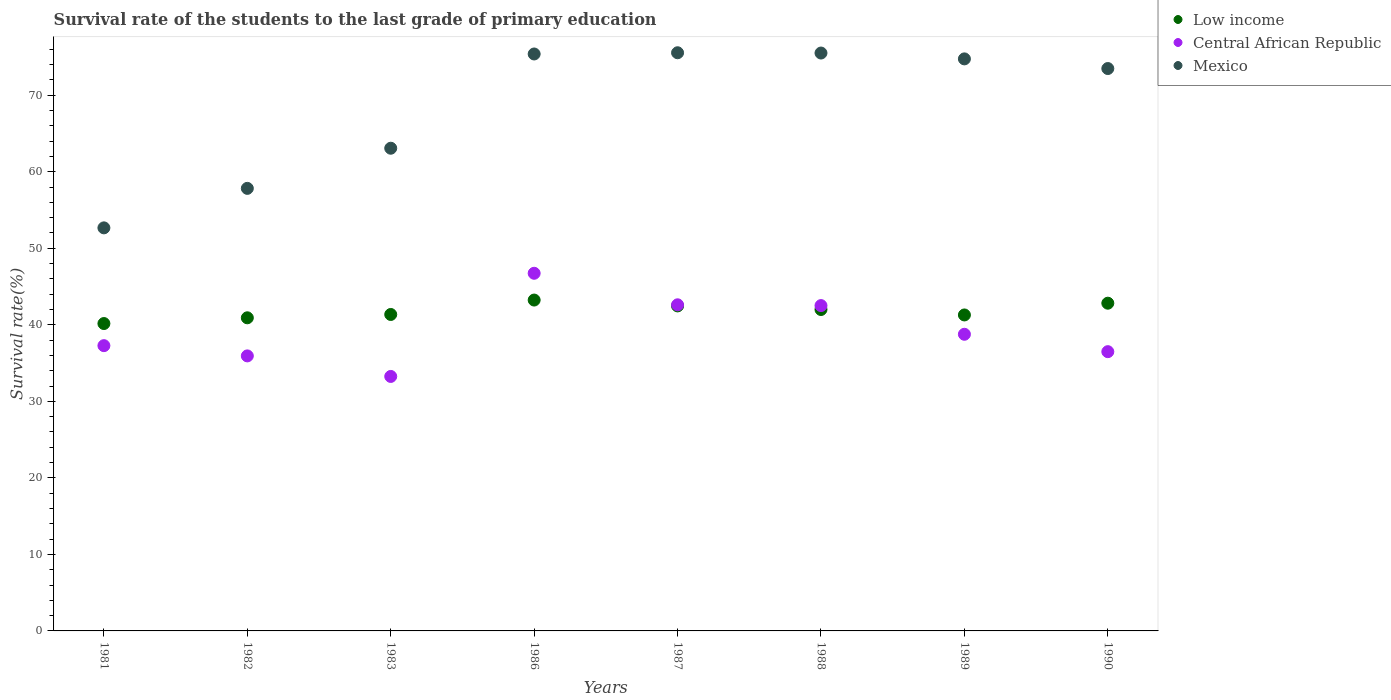Is the number of dotlines equal to the number of legend labels?
Provide a short and direct response. Yes. What is the survival rate of the students in Mexico in 1988?
Make the answer very short. 75.51. Across all years, what is the maximum survival rate of the students in Low income?
Keep it short and to the point. 43.23. Across all years, what is the minimum survival rate of the students in Low income?
Your answer should be very brief. 40.16. What is the total survival rate of the students in Low income in the graph?
Make the answer very short. 334.23. What is the difference between the survival rate of the students in Central African Republic in 1983 and that in 1988?
Provide a succinct answer. -9.26. What is the difference between the survival rate of the students in Low income in 1989 and the survival rate of the students in Central African Republic in 1987?
Provide a short and direct response. -1.33. What is the average survival rate of the students in Mexico per year?
Make the answer very short. 68.53. In the year 1989, what is the difference between the survival rate of the students in Low income and survival rate of the students in Central African Republic?
Provide a succinct answer. 2.52. What is the ratio of the survival rate of the students in Central African Republic in 1983 to that in 1987?
Make the answer very short. 0.78. Is the survival rate of the students in Low income in 1982 less than that in 1987?
Your answer should be compact. Yes. Is the difference between the survival rate of the students in Low income in 1988 and 1989 greater than the difference between the survival rate of the students in Central African Republic in 1988 and 1989?
Keep it short and to the point. No. What is the difference between the highest and the second highest survival rate of the students in Central African Republic?
Make the answer very short. 4.12. What is the difference between the highest and the lowest survival rate of the students in Central African Republic?
Offer a terse response. 13.48. In how many years, is the survival rate of the students in Central African Republic greater than the average survival rate of the students in Central African Republic taken over all years?
Keep it short and to the point. 3. Is the sum of the survival rate of the students in Central African Republic in 1986 and 1987 greater than the maximum survival rate of the students in Mexico across all years?
Ensure brevity in your answer.  Yes. Is it the case that in every year, the sum of the survival rate of the students in Central African Republic and survival rate of the students in Mexico  is greater than the survival rate of the students in Low income?
Your answer should be very brief. Yes. Does the survival rate of the students in Central African Republic monotonically increase over the years?
Your answer should be very brief. No. Is the survival rate of the students in Central African Republic strictly greater than the survival rate of the students in Mexico over the years?
Ensure brevity in your answer.  No. Is the survival rate of the students in Mexico strictly less than the survival rate of the students in Central African Republic over the years?
Offer a very short reply. No. How many dotlines are there?
Provide a succinct answer. 3. How many years are there in the graph?
Offer a very short reply. 8. Are the values on the major ticks of Y-axis written in scientific E-notation?
Provide a short and direct response. No. Where does the legend appear in the graph?
Keep it short and to the point. Top right. How many legend labels are there?
Provide a short and direct response. 3. How are the legend labels stacked?
Offer a very short reply. Vertical. What is the title of the graph?
Offer a very short reply. Survival rate of the students to the last grade of primary education. What is the label or title of the X-axis?
Your answer should be very brief. Years. What is the label or title of the Y-axis?
Your answer should be compact. Survival rate(%). What is the Survival rate(%) of Low income in 1981?
Make the answer very short. 40.16. What is the Survival rate(%) of Central African Republic in 1981?
Keep it short and to the point. 37.27. What is the Survival rate(%) in Mexico in 1981?
Give a very brief answer. 52.67. What is the Survival rate(%) in Low income in 1982?
Provide a short and direct response. 40.91. What is the Survival rate(%) in Central African Republic in 1982?
Keep it short and to the point. 35.94. What is the Survival rate(%) of Mexico in 1982?
Offer a very short reply. 57.83. What is the Survival rate(%) of Low income in 1983?
Make the answer very short. 41.35. What is the Survival rate(%) of Central African Republic in 1983?
Make the answer very short. 33.25. What is the Survival rate(%) of Mexico in 1983?
Your answer should be very brief. 63.07. What is the Survival rate(%) of Low income in 1986?
Your answer should be very brief. 43.23. What is the Survival rate(%) in Central African Republic in 1986?
Provide a short and direct response. 46.73. What is the Survival rate(%) of Mexico in 1986?
Provide a short and direct response. 75.39. What is the Survival rate(%) of Low income in 1987?
Your answer should be very brief. 42.47. What is the Survival rate(%) in Central African Republic in 1987?
Offer a very short reply. 42.61. What is the Survival rate(%) of Mexico in 1987?
Keep it short and to the point. 75.55. What is the Survival rate(%) of Low income in 1988?
Make the answer very short. 42. What is the Survival rate(%) of Central African Republic in 1988?
Your answer should be very brief. 42.51. What is the Survival rate(%) in Mexico in 1988?
Offer a terse response. 75.51. What is the Survival rate(%) of Low income in 1989?
Your answer should be compact. 41.29. What is the Survival rate(%) of Central African Republic in 1989?
Keep it short and to the point. 38.76. What is the Survival rate(%) in Mexico in 1989?
Give a very brief answer. 74.74. What is the Survival rate(%) in Low income in 1990?
Provide a short and direct response. 42.82. What is the Survival rate(%) of Central African Republic in 1990?
Your answer should be compact. 36.49. What is the Survival rate(%) of Mexico in 1990?
Ensure brevity in your answer.  73.48. Across all years, what is the maximum Survival rate(%) in Low income?
Make the answer very short. 43.23. Across all years, what is the maximum Survival rate(%) of Central African Republic?
Make the answer very short. 46.73. Across all years, what is the maximum Survival rate(%) in Mexico?
Your answer should be compact. 75.55. Across all years, what is the minimum Survival rate(%) of Low income?
Provide a short and direct response. 40.16. Across all years, what is the minimum Survival rate(%) in Central African Republic?
Ensure brevity in your answer.  33.25. Across all years, what is the minimum Survival rate(%) in Mexico?
Make the answer very short. 52.67. What is the total Survival rate(%) of Low income in the graph?
Give a very brief answer. 334.23. What is the total Survival rate(%) in Central African Republic in the graph?
Your answer should be compact. 313.57. What is the total Survival rate(%) in Mexico in the graph?
Offer a terse response. 548.23. What is the difference between the Survival rate(%) of Low income in 1981 and that in 1982?
Your answer should be very brief. -0.75. What is the difference between the Survival rate(%) in Central African Republic in 1981 and that in 1982?
Give a very brief answer. 1.34. What is the difference between the Survival rate(%) in Mexico in 1981 and that in 1982?
Keep it short and to the point. -5.16. What is the difference between the Survival rate(%) of Low income in 1981 and that in 1983?
Your answer should be compact. -1.18. What is the difference between the Survival rate(%) in Central African Republic in 1981 and that in 1983?
Provide a short and direct response. 4.02. What is the difference between the Survival rate(%) of Mexico in 1981 and that in 1983?
Provide a succinct answer. -10.4. What is the difference between the Survival rate(%) of Low income in 1981 and that in 1986?
Offer a very short reply. -3.07. What is the difference between the Survival rate(%) of Central African Republic in 1981 and that in 1986?
Make the answer very short. -9.46. What is the difference between the Survival rate(%) in Mexico in 1981 and that in 1986?
Give a very brief answer. -22.72. What is the difference between the Survival rate(%) of Low income in 1981 and that in 1987?
Give a very brief answer. -2.3. What is the difference between the Survival rate(%) of Central African Republic in 1981 and that in 1987?
Provide a short and direct response. -5.34. What is the difference between the Survival rate(%) of Mexico in 1981 and that in 1987?
Your answer should be very brief. -22.88. What is the difference between the Survival rate(%) in Low income in 1981 and that in 1988?
Ensure brevity in your answer.  -1.83. What is the difference between the Survival rate(%) of Central African Republic in 1981 and that in 1988?
Your answer should be compact. -5.23. What is the difference between the Survival rate(%) in Mexico in 1981 and that in 1988?
Keep it short and to the point. -22.84. What is the difference between the Survival rate(%) in Low income in 1981 and that in 1989?
Your answer should be very brief. -1.12. What is the difference between the Survival rate(%) of Central African Republic in 1981 and that in 1989?
Make the answer very short. -1.49. What is the difference between the Survival rate(%) in Mexico in 1981 and that in 1989?
Give a very brief answer. -22.08. What is the difference between the Survival rate(%) in Low income in 1981 and that in 1990?
Offer a terse response. -2.66. What is the difference between the Survival rate(%) in Central African Republic in 1981 and that in 1990?
Ensure brevity in your answer.  0.79. What is the difference between the Survival rate(%) of Mexico in 1981 and that in 1990?
Provide a succinct answer. -20.82. What is the difference between the Survival rate(%) of Low income in 1982 and that in 1983?
Offer a very short reply. -0.44. What is the difference between the Survival rate(%) in Central African Republic in 1982 and that in 1983?
Keep it short and to the point. 2.68. What is the difference between the Survival rate(%) in Mexico in 1982 and that in 1983?
Make the answer very short. -5.25. What is the difference between the Survival rate(%) in Low income in 1982 and that in 1986?
Ensure brevity in your answer.  -2.32. What is the difference between the Survival rate(%) in Central African Republic in 1982 and that in 1986?
Keep it short and to the point. -10.8. What is the difference between the Survival rate(%) in Mexico in 1982 and that in 1986?
Your answer should be very brief. -17.56. What is the difference between the Survival rate(%) in Low income in 1982 and that in 1987?
Offer a terse response. -1.55. What is the difference between the Survival rate(%) of Central African Republic in 1982 and that in 1987?
Keep it short and to the point. -6.68. What is the difference between the Survival rate(%) in Mexico in 1982 and that in 1987?
Ensure brevity in your answer.  -17.72. What is the difference between the Survival rate(%) of Low income in 1982 and that in 1988?
Ensure brevity in your answer.  -1.08. What is the difference between the Survival rate(%) in Central African Republic in 1982 and that in 1988?
Keep it short and to the point. -6.57. What is the difference between the Survival rate(%) of Mexico in 1982 and that in 1988?
Ensure brevity in your answer.  -17.68. What is the difference between the Survival rate(%) in Low income in 1982 and that in 1989?
Offer a terse response. -0.37. What is the difference between the Survival rate(%) of Central African Republic in 1982 and that in 1989?
Give a very brief answer. -2.83. What is the difference between the Survival rate(%) in Mexico in 1982 and that in 1989?
Keep it short and to the point. -16.92. What is the difference between the Survival rate(%) in Low income in 1982 and that in 1990?
Your answer should be compact. -1.91. What is the difference between the Survival rate(%) in Central African Republic in 1982 and that in 1990?
Give a very brief answer. -0.55. What is the difference between the Survival rate(%) in Mexico in 1982 and that in 1990?
Make the answer very short. -15.66. What is the difference between the Survival rate(%) in Low income in 1983 and that in 1986?
Provide a succinct answer. -1.88. What is the difference between the Survival rate(%) of Central African Republic in 1983 and that in 1986?
Keep it short and to the point. -13.48. What is the difference between the Survival rate(%) of Mexico in 1983 and that in 1986?
Keep it short and to the point. -12.31. What is the difference between the Survival rate(%) of Low income in 1983 and that in 1987?
Your answer should be very brief. -1.12. What is the difference between the Survival rate(%) of Central African Republic in 1983 and that in 1987?
Your answer should be compact. -9.36. What is the difference between the Survival rate(%) of Mexico in 1983 and that in 1987?
Your answer should be very brief. -12.47. What is the difference between the Survival rate(%) of Low income in 1983 and that in 1988?
Offer a very short reply. -0.65. What is the difference between the Survival rate(%) in Central African Republic in 1983 and that in 1988?
Your response must be concise. -9.26. What is the difference between the Survival rate(%) of Mexico in 1983 and that in 1988?
Provide a short and direct response. -12.44. What is the difference between the Survival rate(%) in Low income in 1983 and that in 1989?
Offer a very short reply. 0.06. What is the difference between the Survival rate(%) in Central African Republic in 1983 and that in 1989?
Offer a terse response. -5.51. What is the difference between the Survival rate(%) in Mexico in 1983 and that in 1989?
Offer a very short reply. -11.67. What is the difference between the Survival rate(%) in Low income in 1983 and that in 1990?
Provide a succinct answer. -1.47. What is the difference between the Survival rate(%) of Central African Republic in 1983 and that in 1990?
Give a very brief answer. -3.24. What is the difference between the Survival rate(%) of Mexico in 1983 and that in 1990?
Your answer should be compact. -10.41. What is the difference between the Survival rate(%) of Low income in 1986 and that in 1987?
Keep it short and to the point. 0.77. What is the difference between the Survival rate(%) of Central African Republic in 1986 and that in 1987?
Offer a terse response. 4.12. What is the difference between the Survival rate(%) of Mexico in 1986 and that in 1987?
Provide a short and direct response. -0.16. What is the difference between the Survival rate(%) in Low income in 1986 and that in 1988?
Offer a terse response. 1.24. What is the difference between the Survival rate(%) in Central African Republic in 1986 and that in 1988?
Keep it short and to the point. 4.22. What is the difference between the Survival rate(%) in Mexico in 1986 and that in 1988?
Make the answer very short. -0.12. What is the difference between the Survival rate(%) in Low income in 1986 and that in 1989?
Make the answer very short. 1.95. What is the difference between the Survival rate(%) of Central African Republic in 1986 and that in 1989?
Offer a terse response. 7.97. What is the difference between the Survival rate(%) in Mexico in 1986 and that in 1989?
Give a very brief answer. 0.64. What is the difference between the Survival rate(%) in Low income in 1986 and that in 1990?
Provide a short and direct response. 0.41. What is the difference between the Survival rate(%) in Central African Republic in 1986 and that in 1990?
Your response must be concise. 10.24. What is the difference between the Survival rate(%) of Mexico in 1986 and that in 1990?
Provide a short and direct response. 1.9. What is the difference between the Survival rate(%) of Low income in 1987 and that in 1988?
Provide a succinct answer. 0.47. What is the difference between the Survival rate(%) of Central African Republic in 1987 and that in 1988?
Provide a short and direct response. 0.1. What is the difference between the Survival rate(%) in Mexico in 1987 and that in 1988?
Keep it short and to the point. 0.04. What is the difference between the Survival rate(%) in Low income in 1987 and that in 1989?
Make the answer very short. 1.18. What is the difference between the Survival rate(%) in Central African Republic in 1987 and that in 1989?
Offer a terse response. 3.85. What is the difference between the Survival rate(%) in Mexico in 1987 and that in 1989?
Give a very brief answer. 0.8. What is the difference between the Survival rate(%) of Low income in 1987 and that in 1990?
Your response must be concise. -0.35. What is the difference between the Survival rate(%) of Central African Republic in 1987 and that in 1990?
Keep it short and to the point. 6.12. What is the difference between the Survival rate(%) of Mexico in 1987 and that in 1990?
Your answer should be compact. 2.06. What is the difference between the Survival rate(%) in Low income in 1988 and that in 1989?
Make the answer very short. 0.71. What is the difference between the Survival rate(%) in Central African Republic in 1988 and that in 1989?
Keep it short and to the point. 3.75. What is the difference between the Survival rate(%) in Mexico in 1988 and that in 1989?
Offer a very short reply. 0.76. What is the difference between the Survival rate(%) of Low income in 1988 and that in 1990?
Provide a short and direct response. -0.82. What is the difference between the Survival rate(%) of Central African Republic in 1988 and that in 1990?
Offer a very short reply. 6.02. What is the difference between the Survival rate(%) in Mexico in 1988 and that in 1990?
Your answer should be compact. 2.03. What is the difference between the Survival rate(%) in Low income in 1989 and that in 1990?
Offer a terse response. -1.54. What is the difference between the Survival rate(%) of Central African Republic in 1989 and that in 1990?
Your response must be concise. 2.27. What is the difference between the Survival rate(%) in Mexico in 1989 and that in 1990?
Keep it short and to the point. 1.26. What is the difference between the Survival rate(%) of Low income in 1981 and the Survival rate(%) of Central African Republic in 1982?
Keep it short and to the point. 4.23. What is the difference between the Survival rate(%) of Low income in 1981 and the Survival rate(%) of Mexico in 1982?
Your answer should be very brief. -17.66. What is the difference between the Survival rate(%) in Central African Republic in 1981 and the Survival rate(%) in Mexico in 1982?
Offer a terse response. -20.55. What is the difference between the Survival rate(%) in Low income in 1981 and the Survival rate(%) in Central African Republic in 1983?
Offer a very short reply. 6.91. What is the difference between the Survival rate(%) in Low income in 1981 and the Survival rate(%) in Mexico in 1983?
Your answer should be very brief. -22.91. What is the difference between the Survival rate(%) of Central African Republic in 1981 and the Survival rate(%) of Mexico in 1983?
Your answer should be compact. -25.8. What is the difference between the Survival rate(%) in Low income in 1981 and the Survival rate(%) in Central African Republic in 1986?
Keep it short and to the point. -6.57. What is the difference between the Survival rate(%) of Low income in 1981 and the Survival rate(%) of Mexico in 1986?
Provide a succinct answer. -35.22. What is the difference between the Survival rate(%) in Central African Republic in 1981 and the Survival rate(%) in Mexico in 1986?
Give a very brief answer. -38.11. What is the difference between the Survival rate(%) of Low income in 1981 and the Survival rate(%) of Central African Republic in 1987?
Offer a very short reply. -2.45. What is the difference between the Survival rate(%) of Low income in 1981 and the Survival rate(%) of Mexico in 1987?
Ensure brevity in your answer.  -35.38. What is the difference between the Survival rate(%) of Central African Republic in 1981 and the Survival rate(%) of Mexico in 1987?
Offer a terse response. -38.27. What is the difference between the Survival rate(%) in Low income in 1981 and the Survival rate(%) in Central African Republic in 1988?
Your answer should be compact. -2.35. What is the difference between the Survival rate(%) in Low income in 1981 and the Survival rate(%) in Mexico in 1988?
Your response must be concise. -35.34. What is the difference between the Survival rate(%) in Central African Republic in 1981 and the Survival rate(%) in Mexico in 1988?
Ensure brevity in your answer.  -38.23. What is the difference between the Survival rate(%) of Low income in 1981 and the Survival rate(%) of Central African Republic in 1989?
Your answer should be very brief. 1.4. What is the difference between the Survival rate(%) in Low income in 1981 and the Survival rate(%) in Mexico in 1989?
Offer a very short reply. -34.58. What is the difference between the Survival rate(%) of Central African Republic in 1981 and the Survival rate(%) of Mexico in 1989?
Offer a terse response. -37.47. What is the difference between the Survival rate(%) of Low income in 1981 and the Survival rate(%) of Central African Republic in 1990?
Your answer should be compact. 3.68. What is the difference between the Survival rate(%) of Low income in 1981 and the Survival rate(%) of Mexico in 1990?
Your response must be concise. -33.32. What is the difference between the Survival rate(%) in Central African Republic in 1981 and the Survival rate(%) in Mexico in 1990?
Give a very brief answer. -36.21. What is the difference between the Survival rate(%) of Low income in 1982 and the Survival rate(%) of Central African Republic in 1983?
Your answer should be very brief. 7.66. What is the difference between the Survival rate(%) in Low income in 1982 and the Survival rate(%) in Mexico in 1983?
Ensure brevity in your answer.  -22.16. What is the difference between the Survival rate(%) in Central African Republic in 1982 and the Survival rate(%) in Mexico in 1983?
Keep it short and to the point. -27.14. What is the difference between the Survival rate(%) of Low income in 1982 and the Survival rate(%) of Central African Republic in 1986?
Your answer should be very brief. -5.82. What is the difference between the Survival rate(%) of Low income in 1982 and the Survival rate(%) of Mexico in 1986?
Provide a succinct answer. -34.47. What is the difference between the Survival rate(%) in Central African Republic in 1982 and the Survival rate(%) in Mexico in 1986?
Your answer should be compact. -39.45. What is the difference between the Survival rate(%) in Low income in 1982 and the Survival rate(%) in Central African Republic in 1987?
Make the answer very short. -1.7. What is the difference between the Survival rate(%) of Low income in 1982 and the Survival rate(%) of Mexico in 1987?
Your response must be concise. -34.63. What is the difference between the Survival rate(%) in Central African Republic in 1982 and the Survival rate(%) in Mexico in 1987?
Your answer should be compact. -39.61. What is the difference between the Survival rate(%) of Low income in 1982 and the Survival rate(%) of Central African Republic in 1988?
Keep it short and to the point. -1.6. What is the difference between the Survival rate(%) in Low income in 1982 and the Survival rate(%) in Mexico in 1988?
Your answer should be compact. -34.6. What is the difference between the Survival rate(%) of Central African Republic in 1982 and the Survival rate(%) of Mexico in 1988?
Give a very brief answer. -39.57. What is the difference between the Survival rate(%) of Low income in 1982 and the Survival rate(%) of Central African Republic in 1989?
Your answer should be very brief. 2.15. What is the difference between the Survival rate(%) of Low income in 1982 and the Survival rate(%) of Mexico in 1989?
Ensure brevity in your answer.  -33.83. What is the difference between the Survival rate(%) of Central African Republic in 1982 and the Survival rate(%) of Mexico in 1989?
Give a very brief answer. -38.81. What is the difference between the Survival rate(%) of Low income in 1982 and the Survival rate(%) of Central African Republic in 1990?
Ensure brevity in your answer.  4.42. What is the difference between the Survival rate(%) in Low income in 1982 and the Survival rate(%) in Mexico in 1990?
Make the answer very short. -32.57. What is the difference between the Survival rate(%) of Central African Republic in 1982 and the Survival rate(%) of Mexico in 1990?
Give a very brief answer. -37.55. What is the difference between the Survival rate(%) in Low income in 1983 and the Survival rate(%) in Central African Republic in 1986?
Offer a very short reply. -5.38. What is the difference between the Survival rate(%) of Low income in 1983 and the Survival rate(%) of Mexico in 1986?
Make the answer very short. -34.04. What is the difference between the Survival rate(%) of Central African Republic in 1983 and the Survival rate(%) of Mexico in 1986?
Provide a short and direct response. -42.13. What is the difference between the Survival rate(%) in Low income in 1983 and the Survival rate(%) in Central African Republic in 1987?
Provide a short and direct response. -1.26. What is the difference between the Survival rate(%) of Low income in 1983 and the Survival rate(%) of Mexico in 1987?
Give a very brief answer. -34.2. What is the difference between the Survival rate(%) in Central African Republic in 1983 and the Survival rate(%) in Mexico in 1987?
Your response must be concise. -42.29. What is the difference between the Survival rate(%) of Low income in 1983 and the Survival rate(%) of Central African Republic in 1988?
Offer a very short reply. -1.16. What is the difference between the Survival rate(%) of Low income in 1983 and the Survival rate(%) of Mexico in 1988?
Your answer should be compact. -34.16. What is the difference between the Survival rate(%) in Central African Republic in 1983 and the Survival rate(%) in Mexico in 1988?
Give a very brief answer. -42.26. What is the difference between the Survival rate(%) in Low income in 1983 and the Survival rate(%) in Central African Republic in 1989?
Your answer should be compact. 2.59. What is the difference between the Survival rate(%) in Low income in 1983 and the Survival rate(%) in Mexico in 1989?
Your answer should be compact. -33.4. What is the difference between the Survival rate(%) in Central African Republic in 1983 and the Survival rate(%) in Mexico in 1989?
Your answer should be compact. -41.49. What is the difference between the Survival rate(%) in Low income in 1983 and the Survival rate(%) in Central African Republic in 1990?
Provide a succinct answer. 4.86. What is the difference between the Survival rate(%) of Low income in 1983 and the Survival rate(%) of Mexico in 1990?
Keep it short and to the point. -32.13. What is the difference between the Survival rate(%) in Central African Republic in 1983 and the Survival rate(%) in Mexico in 1990?
Give a very brief answer. -40.23. What is the difference between the Survival rate(%) in Low income in 1986 and the Survival rate(%) in Central African Republic in 1987?
Ensure brevity in your answer.  0.62. What is the difference between the Survival rate(%) in Low income in 1986 and the Survival rate(%) in Mexico in 1987?
Make the answer very short. -32.31. What is the difference between the Survival rate(%) of Central African Republic in 1986 and the Survival rate(%) of Mexico in 1987?
Offer a very short reply. -28.81. What is the difference between the Survival rate(%) in Low income in 1986 and the Survival rate(%) in Central African Republic in 1988?
Your answer should be compact. 0.72. What is the difference between the Survival rate(%) of Low income in 1986 and the Survival rate(%) of Mexico in 1988?
Your response must be concise. -32.28. What is the difference between the Survival rate(%) in Central African Republic in 1986 and the Survival rate(%) in Mexico in 1988?
Offer a very short reply. -28.78. What is the difference between the Survival rate(%) of Low income in 1986 and the Survival rate(%) of Central African Republic in 1989?
Your answer should be very brief. 4.47. What is the difference between the Survival rate(%) in Low income in 1986 and the Survival rate(%) in Mexico in 1989?
Offer a very short reply. -31.51. What is the difference between the Survival rate(%) in Central African Republic in 1986 and the Survival rate(%) in Mexico in 1989?
Your response must be concise. -28.01. What is the difference between the Survival rate(%) in Low income in 1986 and the Survival rate(%) in Central African Republic in 1990?
Provide a succinct answer. 6.74. What is the difference between the Survival rate(%) in Low income in 1986 and the Survival rate(%) in Mexico in 1990?
Your answer should be compact. -30.25. What is the difference between the Survival rate(%) of Central African Republic in 1986 and the Survival rate(%) of Mexico in 1990?
Keep it short and to the point. -26.75. What is the difference between the Survival rate(%) in Low income in 1987 and the Survival rate(%) in Central African Republic in 1988?
Provide a short and direct response. -0.04. What is the difference between the Survival rate(%) in Low income in 1987 and the Survival rate(%) in Mexico in 1988?
Your response must be concise. -33.04. What is the difference between the Survival rate(%) in Central African Republic in 1987 and the Survival rate(%) in Mexico in 1988?
Provide a short and direct response. -32.9. What is the difference between the Survival rate(%) in Low income in 1987 and the Survival rate(%) in Central African Republic in 1989?
Offer a terse response. 3.71. What is the difference between the Survival rate(%) of Low income in 1987 and the Survival rate(%) of Mexico in 1989?
Provide a short and direct response. -32.28. What is the difference between the Survival rate(%) in Central African Republic in 1987 and the Survival rate(%) in Mexico in 1989?
Make the answer very short. -32.13. What is the difference between the Survival rate(%) in Low income in 1987 and the Survival rate(%) in Central African Republic in 1990?
Offer a very short reply. 5.98. What is the difference between the Survival rate(%) of Low income in 1987 and the Survival rate(%) of Mexico in 1990?
Offer a very short reply. -31.02. What is the difference between the Survival rate(%) in Central African Republic in 1987 and the Survival rate(%) in Mexico in 1990?
Give a very brief answer. -30.87. What is the difference between the Survival rate(%) in Low income in 1988 and the Survival rate(%) in Central African Republic in 1989?
Offer a terse response. 3.24. What is the difference between the Survival rate(%) of Low income in 1988 and the Survival rate(%) of Mexico in 1989?
Ensure brevity in your answer.  -32.75. What is the difference between the Survival rate(%) of Central African Republic in 1988 and the Survival rate(%) of Mexico in 1989?
Keep it short and to the point. -32.24. What is the difference between the Survival rate(%) in Low income in 1988 and the Survival rate(%) in Central African Republic in 1990?
Your answer should be very brief. 5.51. What is the difference between the Survival rate(%) of Low income in 1988 and the Survival rate(%) of Mexico in 1990?
Provide a short and direct response. -31.49. What is the difference between the Survival rate(%) in Central African Republic in 1988 and the Survival rate(%) in Mexico in 1990?
Your answer should be very brief. -30.97. What is the difference between the Survival rate(%) of Low income in 1989 and the Survival rate(%) of Central African Republic in 1990?
Your response must be concise. 4.8. What is the difference between the Survival rate(%) in Low income in 1989 and the Survival rate(%) in Mexico in 1990?
Offer a very short reply. -32.2. What is the difference between the Survival rate(%) in Central African Republic in 1989 and the Survival rate(%) in Mexico in 1990?
Offer a terse response. -34.72. What is the average Survival rate(%) in Low income per year?
Provide a short and direct response. 41.78. What is the average Survival rate(%) in Central African Republic per year?
Your response must be concise. 39.2. What is the average Survival rate(%) in Mexico per year?
Provide a short and direct response. 68.53. In the year 1981, what is the difference between the Survival rate(%) in Low income and Survival rate(%) in Central African Republic?
Give a very brief answer. 2.89. In the year 1981, what is the difference between the Survival rate(%) in Low income and Survival rate(%) in Mexico?
Offer a very short reply. -12.5. In the year 1981, what is the difference between the Survival rate(%) in Central African Republic and Survival rate(%) in Mexico?
Your answer should be very brief. -15.39. In the year 1982, what is the difference between the Survival rate(%) of Low income and Survival rate(%) of Central African Republic?
Ensure brevity in your answer.  4.98. In the year 1982, what is the difference between the Survival rate(%) of Low income and Survival rate(%) of Mexico?
Provide a short and direct response. -16.91. In the year 1982, what is the difference between the Survival rate(%) in Central African Republic and Survival rate(%) in Mexico?
Offer a terse response. -21.89. In the year 1983, what is the difference between the Survival rate(%) of Low income and Survival rate(%) of Central African Republic?
Give a very brief answer. 8.1. In the year 1983, what is the difference between the Survival rate(%) in Low income and Survival rate(%) in Mexico?
Keep it short and to the point. -21.72. In the year 1983, what is the difference between the Survival rate(%) of Central African Republic and Survival rate(%) of Mexico?
Keep it short and to the point. -29.82. In the year 1986, what is the difference between the Survival rate(%) of Low income and Survival rate(%) of Central African Republic?
Make the answer very short. -3.5. In the year 1986, what is the difference between the Survival rate(%) in Low income and Survival rate(%) in Mexico?
Offer a terse response. -32.15. In the year 1986, what is the difference between the Survival rate(%) of Central African Republic and Survival rate(%) of Mexico?
Provide a short and direct response. -28.65. In the year 1987, what is the difference between the Survival rate(%) in Low income and Survival rate(%) in Central African Republic?
Your answer should be compact. -0.14. In the year 1987, what is the difference between the Survival rate(%) of Low income and Survival rate(%) of Mexico?
Give a very brief answer. -33.08. In the year 1987, what is the difference between the Survival rate(%) in Central African Republic and Survival rate(%) in Mexico?
Make the answer very short. -32.93. In the year 1988, what is the difference between the Survival rate(%) in Low income and Survival rate(%) in Central African Republic?
Keep it short and to the point. -0.51. In the year 1988, what is the difference between the Survival rate(%) of Low income and Survival rate(%) of Mexico?
Your answer should be compact. -33.51. In the year 1988, what is the difference between the Survival rate(%) in Central African Republic and Survival rate(%) in Mexico?
Provide a short and direct response. -33. In the year 1989, what is the difference between the Survival rate(%) of Low income and Survival rate(%) of Central African Republic?
Keep it short and to the point. 2.52. In the year 1989, what is the difference between the Survival rate(%) of Low income and Survival rate(%) of Mexico?
Provide a succinct answer. -33.46. In the year 1989, what is the difference between the Survival rate(%) of Central African Republic and Survival rate(%) of Mexico?
Your response must be concise. -35.98. In the year 1990, what is the difference between the Survival rate(%) in Low income and Survival rate(%) in Central African Republic?
Your answer should be very brief. 6.33. In the year 1990, what is the difference between the Survival rate(%) in Low income and Survival rate(%) in Mexico?
Keep it short and to the point. -30.66. In the year 1990, what is the difference between the Survival rate(%) of Central African Republic and Survival rate(%) of Mexico?
Offer a terse response. -36.99. What is the ratio of the Survival rate(%) in Low income in 1981 to that in 1982?
Offer a very short reply. 0.98. What is the ratio of the Survival rate(%) in Central African Republic in 1981 to that in 1982?
Make the answer very short. 1.04. What is the ratio of the Survival rate(%) in Mexico in 1981 to that in 1982?
Ensure brevity in your answer.  0.91. What is the ratio of the Survival rate(%) of Low income in 1981 to that in 1983?
Give a very brief answer. 0.97. What is the ratio of the Survival rate(%) in Central African Republic in 1981 to that in 1983?
Keep it short and to the point. 1.12. What is the ratio of the Survival rate(%) of Mexico in 1981 to that in 1983?
Offer a terse response. 0.83. What is the ratio of the Survival rate(%) in Low income in 1981 to that in 1986?
Your answer should be compact. 0.93. What is the ratio of the Survival rate(%) in Central African Republic in 1981 to that in 1986?
Provide a short and direct response. 0.8. What is the ratio of the Survival rate(%) of Mexico in 1981 to that in 1986?
Ensure brevity in your answer.  0.7. What is the ratio of the Survival rate(%) in Low income in 1981 to that in 1987?
Keep it short and to the point. 0.95. What is the ratio of the Survival rate(%) of Central African Republic in 1981 to that in 1987?
Make the answer very short. 0.87. What is the ratio of the Survival rate(%) in Mexico in 1981 to that in 1987?
Your answer should be very brief. 0.7. What is the ratio of the Survival rate(%) of Low income in 1981 to that in 1988?
Ensure brevity in your answer.  0.96. What is the ratio of the Survival rate(%) in Central African Republic in 1981 to that in 1988?
Give a very brief answer. 0.88. What is the ratio of the Survival rate(%) of Mexico in 1981 to that in 1988?
Your answer should be compact. 0.7. What is the ratio of the Survival rate(%) of Low income in 1981 to that in 1989?
Provide a succinct answer. 0.97. What is the ratio of the Survival rate(%) of Central African Republic in 1981 to that in 1989?
Offer a terse response. 0.96. What is the ratio of the Survival rate(%) of Mexico in 1981 to that in 1989?
Ensure brevity in your answer.  0.7. What is the ratio of the Survival rate(%) of Low income in 1981 to that in 1990?
Give a very brief answer. 0.94. What is the ratio of the Survival rate(%) in Central African Republic in 1981 to that in 1990?
Provide a short and direct response. 1.02. What is the ratio of the Survival rate(%) of Mexico in 1981 to that in 1990?
Provide a succinct answer. 0.72. What is the ratio of the Survival rate(%) of Central African Republic in 1982 to that in 1983?
Keep it short and to the point. 1.08. What is the ratio of the Survival rate(%) of Mexico in 1982 to that in 1983?
Keep it short and to the point. 0.92. What is the ratio of the Survival rate(%) of Low income in 1982 to that in 1986?
Provide a succinct answer. 0.95. What is the ratio of the Survival rate(%) of Central African Republic in 1982 to that in 1986?
Provide a short and direct response. 0.77. What is the ratio of the Survival rate(%) in Mexico in 1982 to that in 1986?
Keep it short and to the point. 0.77. What is the ratio of the Survival rate(%) in Low income in 1982 to that in 1987?
Your answer should be very brief. 0.96. What is the ratio of the Survival rate(%) of Central African Republic in 1982 to that in 1987?
Your answer should be compact. 0.84. What is the ratio of the Survival rate(%) of Mexico in 1982 to that in 1987?
Offer a terse response. 0.77. What is the ratio of the Survival rate(%) in Low income in 1982 to that in 1988?
Offer a terse response. 0.97. What is the ratio of the Survival rate(%) of Central African Republic in 1982 to that in 1988?
Provide a succinct answer. 0.85. What is the ratio of the Survival rate(%) of Mexico in 1982 to that in 1988?
Make the answer very short. 0.77. What is the ratio of the Survival rate(%) of Low income in 1982 to that in 1989?
Your response must be concise. 0.99. What is the ratio of the Survival rate(%) of Central African Republic in 1982 to that in 1989?
Offer a very short reply. 0.93. What is the ratio of the Survival rate(%) of Mexico in 1982 to that in 1989?
Provide a short and direct response. 0.77. What is the ratio of the Survival rate(%) in Low income in 1982 to that in 1990?
Offer a terse response. 0.96. What is the ratio of the Survival rate(%) in Central African Republic in 1982 to that in 1990?
Make the answer very short. 0.98. What is the ratio of the Survival rate(%) in Mexico in 1982 to that in 1990?
Your answer should be compact. 0.79. What is the ratio of the Survival rate(%) of Low income in 1983 to that in 1986?
Give a very brief answer. 0.96. What is the ratio of the Survival rate(%) of Central African Republic in 1983 to that in 1986?
Your answer should be very brief. 0.71. What is the ratio of the Survival rate(%) of Mexico in 1983 to that in 1986?
Ensure brevity in your answer.  0.84. What is the ratio of the Survival rate(%) of Low income in 1983 to that in 1987?
Provide a short and direct response. 0.97. What is the ratio of the Survival rate(%) of Central African Republic in 1983 to that in 1987?
Your response must be concise. 0.78. What is the ratio of the Survival rate(%) of Mexico in 1983 to that in 1987?
Offer a terse response. 0.83. What is the ratio of the Survival rate(%) of Low income in 1983 to that in 1988?
Make the answer very short. 0.98. What is the ratio of the Survival rate(%) in Central African Republic in 1983 to that in 1988?
Your answer should be compact. 0.78. What is the ratio of the Survival rate(%) in Mexico in 1983 to that in 1988?
Your response must be concise. 0.84. What is the ratio of the Survival rate(%) of Central African Republic in 1983 to that in 1989?
Give a very brief answer. 0.86. What is the ratio of the Survival rate(%) in Mexico in 1983 to that in 1989?
Your answer should be very brief. 0.84. What is the ratio of the Survival rate(%) of Low income in 1983 to that in 1990?
Your answer should be very brief. 0.97. What is the ratio of the Survival rate(%) of Central African Republic in 1983 to that in 1990?
Keep it short and to the point. 0.91. What is the ratio of the Survival rate(%) of Mexico in 1983 to that in 1990?
Ensure brevity in your answer.  0.86. What is the ratio of the Survival rate(%) in Central African Republic in 1986 to that in 1987?
Keep it short and to the point. 1.1. What is the ratio of the Survival rate(%) of Mexico in 1986 to that in 1987?
Your response must be concise. 1. What is the ratio of the Survival rate(%) in Low income in 1986 to that in 1988?
Make the answer very short. 1.03. What is the ratio of the Survival rate(%) in Central African Republic in 1986 to that in 1988?
Your answer should be compact. 1.1. What is the ratio of the Survival rate(%) of Low income in 1986 to that in 1989?
Ensure brevity in your answer.  1.05. What is the ratio of the Survival rate(%) in Central African Republic in 1986 to that in 1989?
Keep it short and to the point. 1.21. What is the ratio of the Survival rate(%) of Mexico in 1986 to that in 1989?
Ensure brevity in your answer.  1.01. What is the ratio of the Survival rate(%) in Low income in 1986 to that in 1990?
Your response must be concise. 1.01. What is the ratio of the Survival rate(%) of Central African Republic in 1986 to that in 1990?
Your answer should be compact. 1.28. What is the ratio of the Survival rate(%) in Mexico in 1986 to that in 1990?
Provide a succinct answer. 1.03. What is the ratio of the Survival rate(%) in Low income in 1987 to that in 1988?
Make the answer very short. 1.01. What is the ratio of the Survival rate(%) in Mexico in 1987 to that in 1988?
Your answer should be very brief. 1. What is the ratio of the Survival rate(%) of Low income in 1987 to that in 1989?
Keep it short and to the point. 1.03. What is the ratio of the Survival rate(%) in Central African Republic in 1987 to that in 1989?
Provide a succinct answer. 1.1. What is the ratio of the Survival rate(%) in Mexico in 1987 to that in 1989?
Make the answer very short. 1.01. What is the ratio of the Survival rate(%) of Central African Republic in 1987 to that in 1990?
Provide a short and direct response. 1.17. What is the ratio of the Survival rate(%) of Mexico in 1987 to that in 1990?
Your answer should be very brief. 1.03. What is the ratio of the Survival rate(%) in Low income in 1988 to that in 1989?
Offer a terse response. 1.02. What is the ratio of the Survival rate(%) of Central African Republic in 1988 to that in 1989?
Ensure brevity in your answer.  1.1. What is the ratio of the Survival rate(%) of Mexico in 1988 to that in 1989?
Make the answer very short. 1.01. What is the ratio of the Survival rate(%) of Low income in 1988 to that in 1990?
Provide a short and direct response. 0.98. What is the ratio of the Survival rate(%) of Central African Republic in 1988 to that in 1990?
Your answer should be very brief. 1.17. What is the ratio of the Survival rate(%) of Mexico in 1988 to that in 1990?
Offer a very short reply. 1.03. What is the ratio of the Survival rate(%) in Low income in 1989 to that in 1990?
Ensure brevity in your answer.  0.96. What is the ratio of the Survival rate(%) of Central African Republic in 1989 to that in 1990?
Ensure brevity in your answer.  1.06. What is the ratio of the Survival rate(%) of Mexico in 1989 to that in 1990?
Provide a short and direct response. 1.02. What is the difference between the highest and the second highest Survival rate(%) in Low income?
Your response must be concise. 0.41. What is the difference between the highest and the second highest Survival rate(%) of Central African Republic?
Offer a very short reply. 4.12. What is the difference between the highest and the second highest Survival rate(%) of Mexico?
Offer a terse response. 0.04. What is the difference between the highest and the lowest Survival rate(%) of Low income?
Your response must be concise. 3.07. What is the difference between the highest and the lowest Survival rate(%) in Central African Republic?
Make the answer very short. 13.48. What is the difference between the highest and the lowest Survival rate(%) of Mexico?
Your answer should be compact. 22.88. 